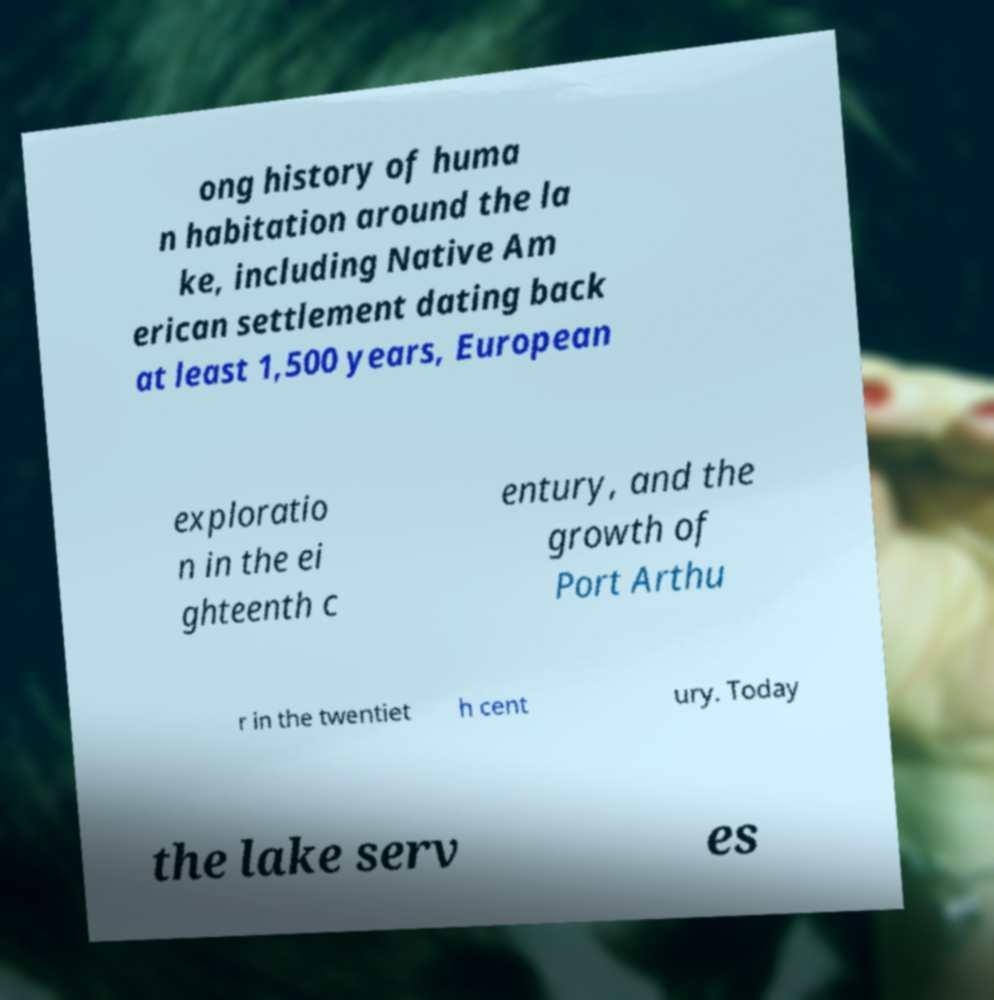Please identify and transcribe the text found in this image. ong history of huma n habitation around the la ke, including Native Am erican settlement dating back at least 1,500 years, European exploratio n in the ei ghteenth c entury, and the growth of Port Arthu r in the twentiet h cent ury. Today the lake serv es 